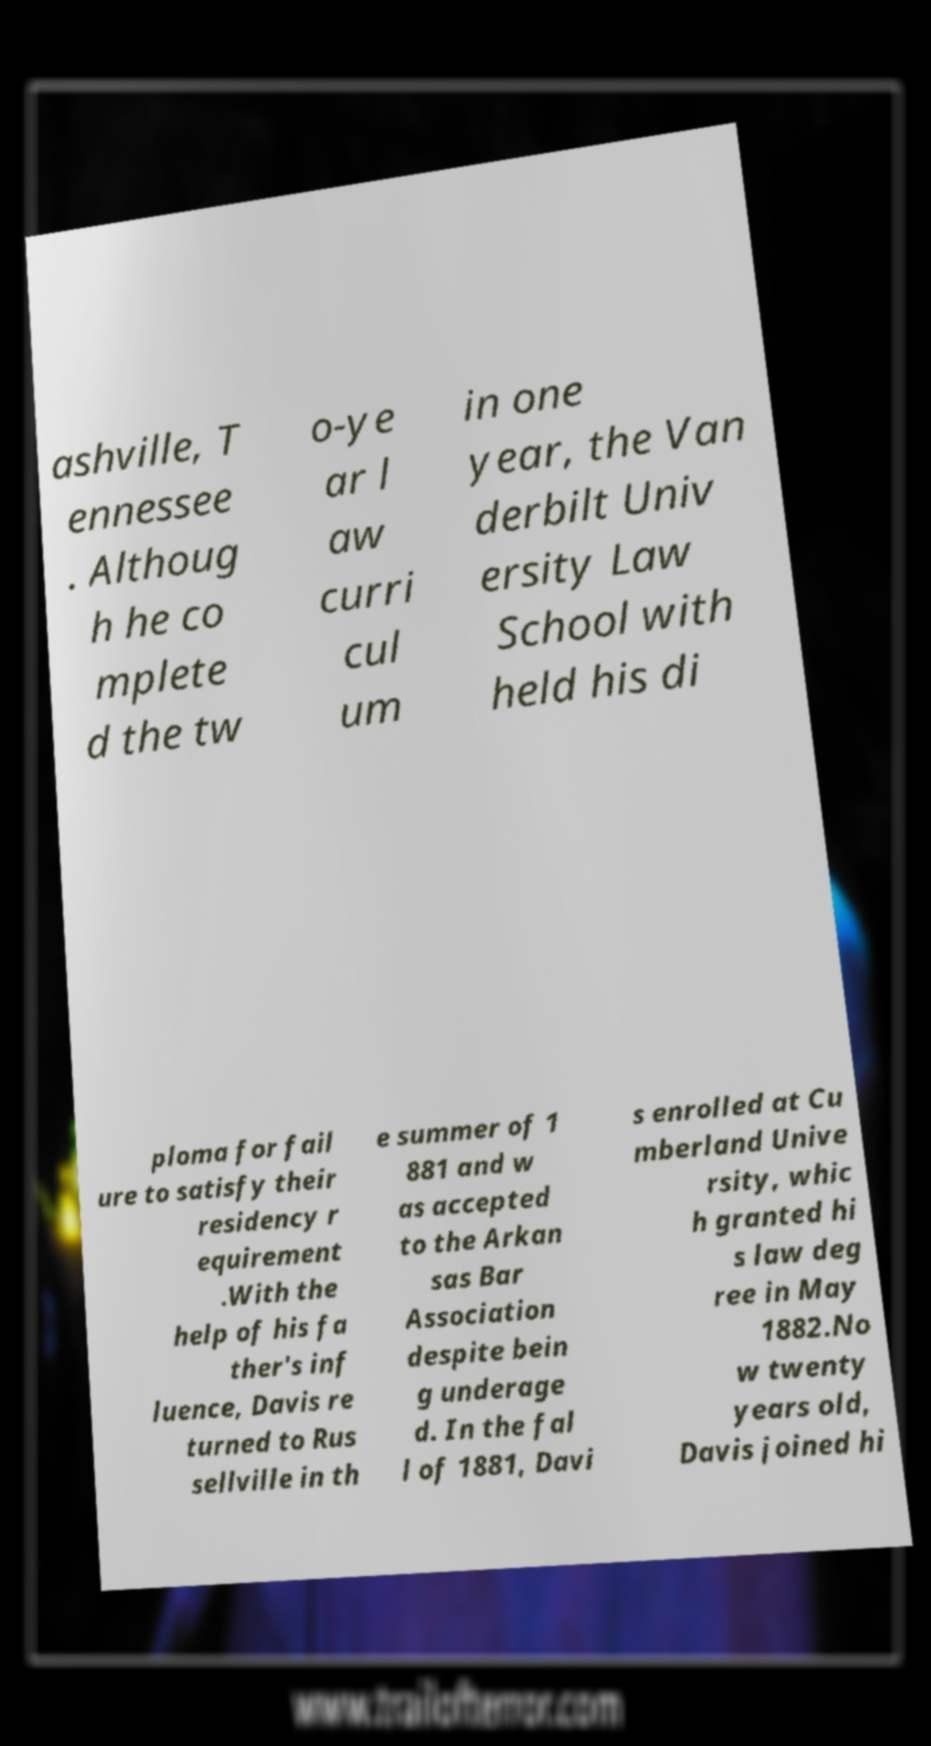I need the written content from this picture converted into text. Can you do that? ashville, T ennessee . Althoug h he co mplete d the tw o-ye ar l aw curri cul um in one year, the Van derbilt Univ ersity Law School with held his di ploma for fail ure to satisfy their residency r equirement .With the help of his fa ther's inf luence, Davis re turned to Rus sellville in th e summer of 1 881 and w as accepted to the Arkan sas Bar Association despite bein g underage d. In the fal l of 1881, Davi s enrolled at Cu mberland Unive rsity, whic h granted hi s law deg ree in May 1882.No w twenty years old, Davis joined hi 